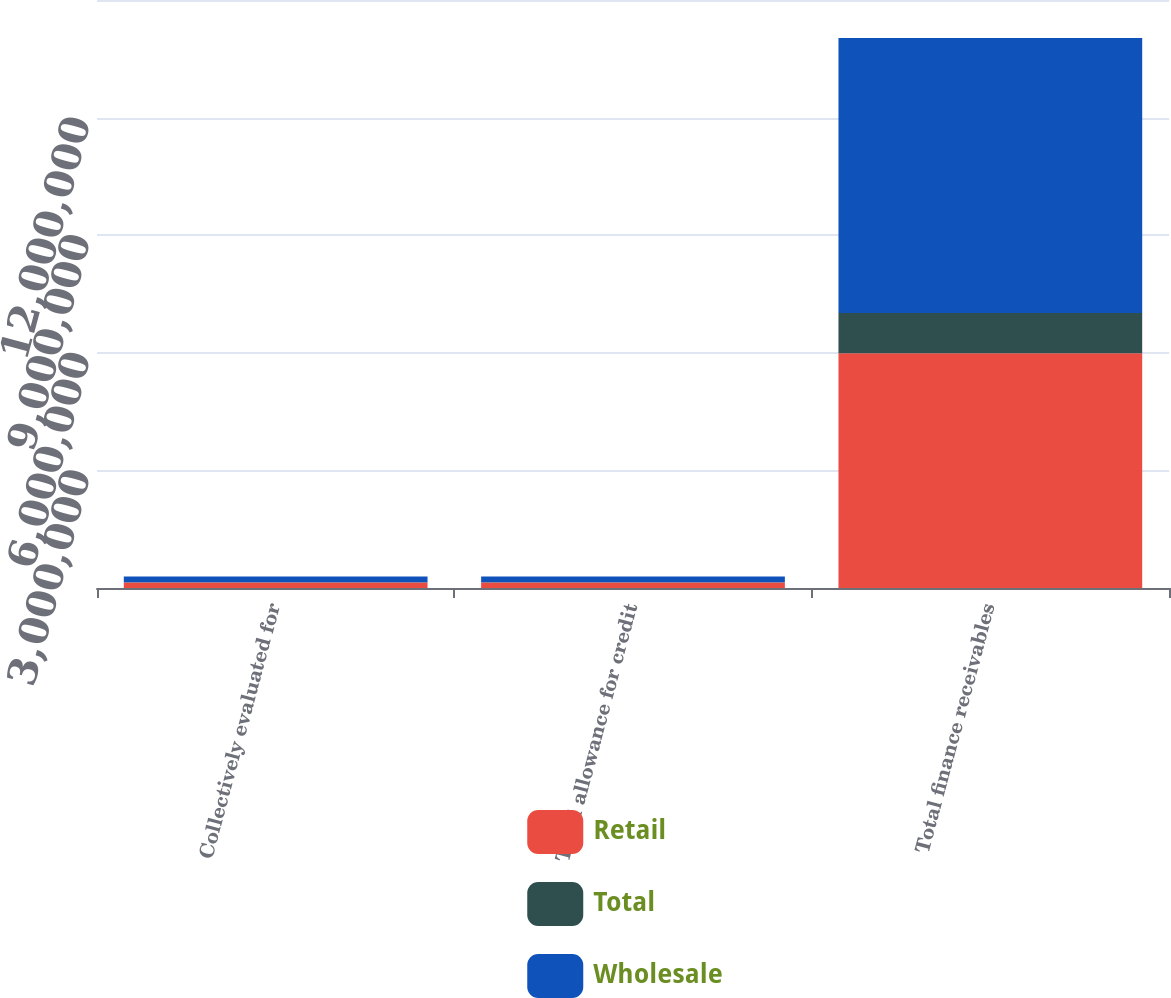<chart> <loc_0><loc_0><loc_500><loc_500><stacked_bar_chart><ecel><fcel>Collectively evaluated for<fcel>Total allowance for credit<fcel>Total finance receivables<nl><fcel>Retail<fcel>139320<fcel>139320<fcel>5.99147e+06<nl><fcel>Total<fcel>7858<fcel>7858<fcel>1.02386e+06<nl><fcel>Wholesale<fcel>147178<fcel>147178<fcel>7.01533e+06<nl></chart> 